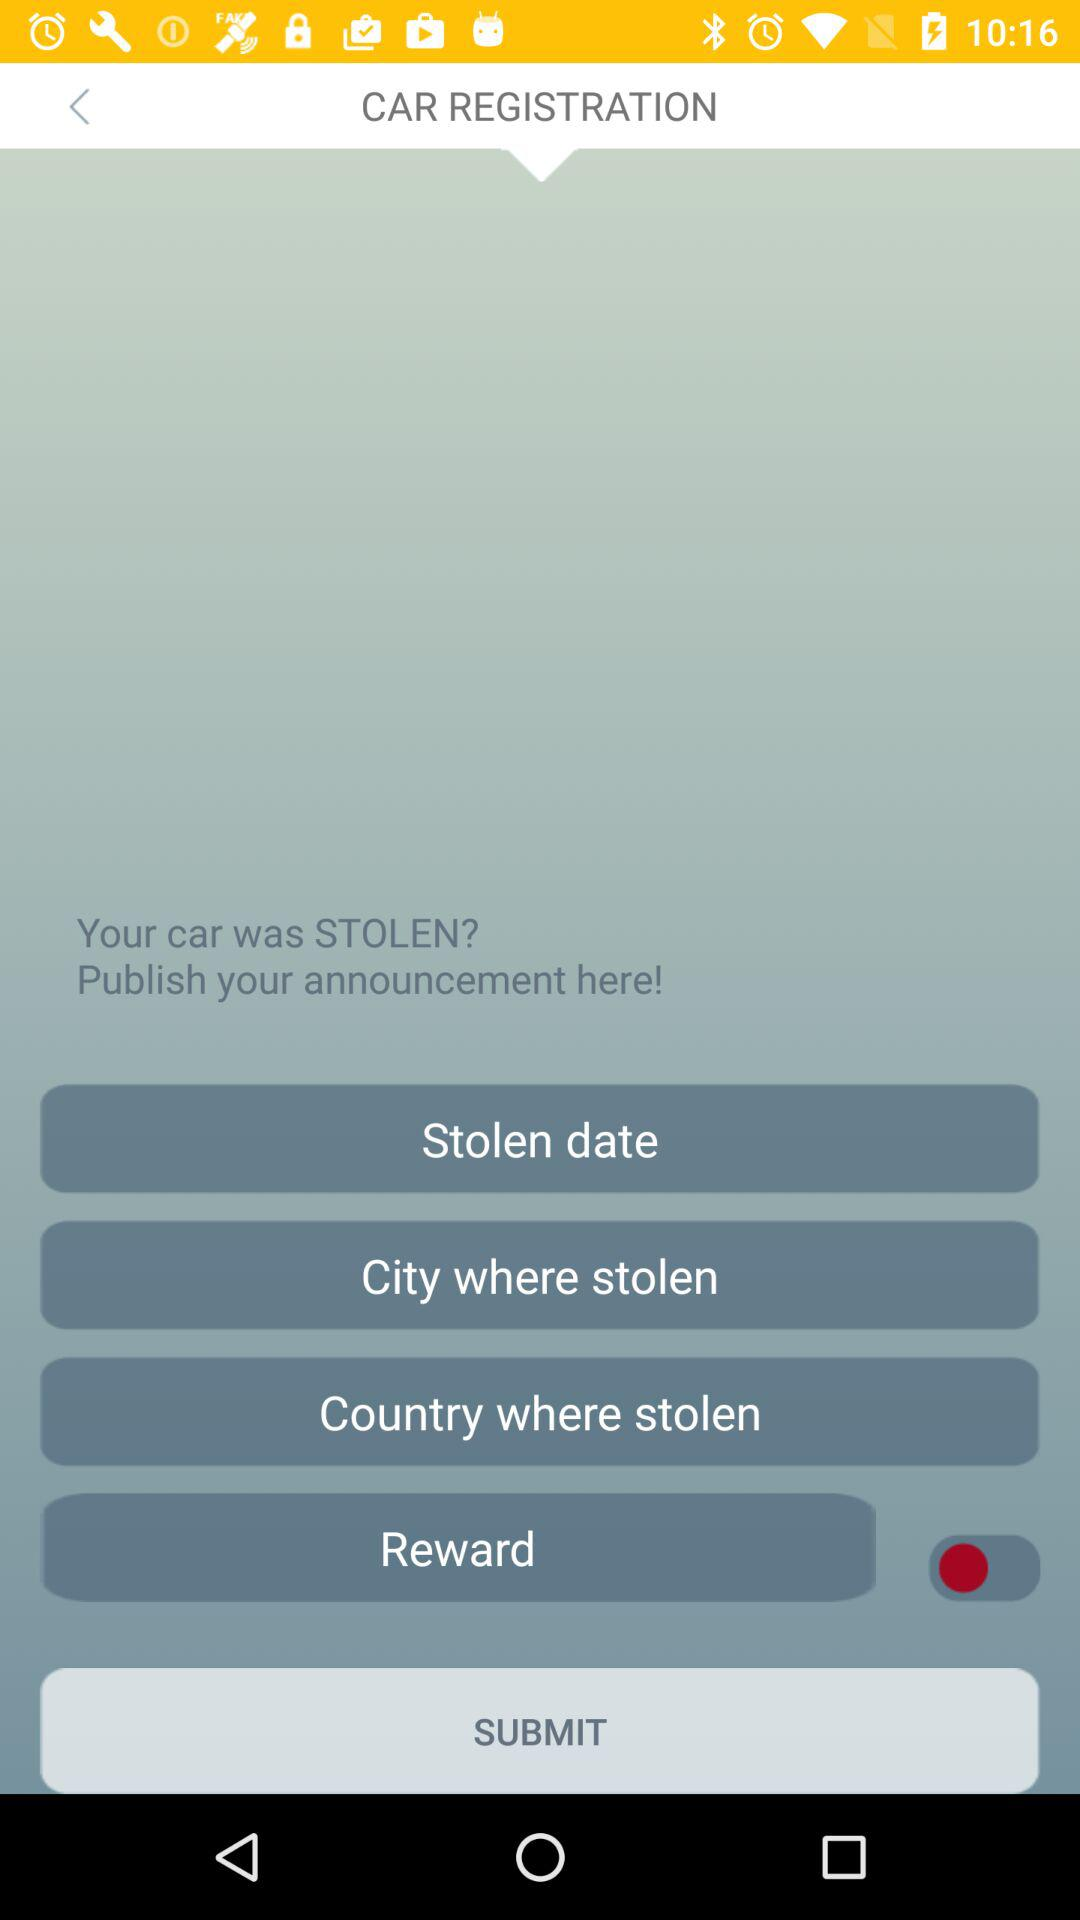When was the car stolen?
When the provided information is insufficient, respond with <no answer>. <no answer> 